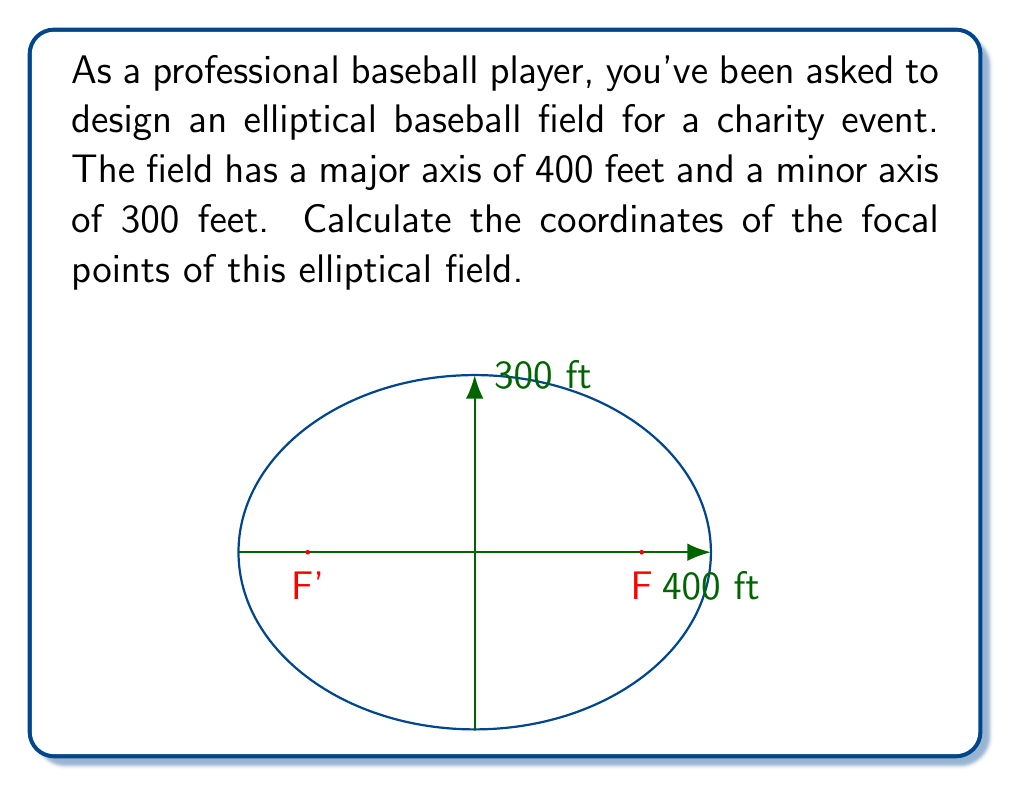Provide a solution to this math problem. Let's approach this step-by-step:

1) For an ellipse, we know that:
   $$a^2 = b^2 + c^2$$
   where $a$ is half the major axis, $b$ is half the minor axis, and $c$ is the distance from the center to a focus.

2) In this case:
   $a = 200$ feet (half of 400 feet)
   $b = 150$ feet (half of 300 feet)

3) Let's substitute these values into the equation:
   $$200^2 = 150^2 + c^2$$

4) Simplify:
   $$40000 = 22500 + c^2$$

5) Subtract 22500 from both sides:
   $$17500 = c^2$$

6) Take the square root of both sides:
   $$c = \sqrt{17500} \approx 132.3$$

7) The focal points are located $c$ units to the left and right of the center on the major axis. Since the center is at (0,0), the coordinates are:
   $$(\pm 132.3, 0)$$

8) Rounding to one decimal place:
   $$(±132.3, 0)$$
Answer: $$(±132.3, 0)$$ 